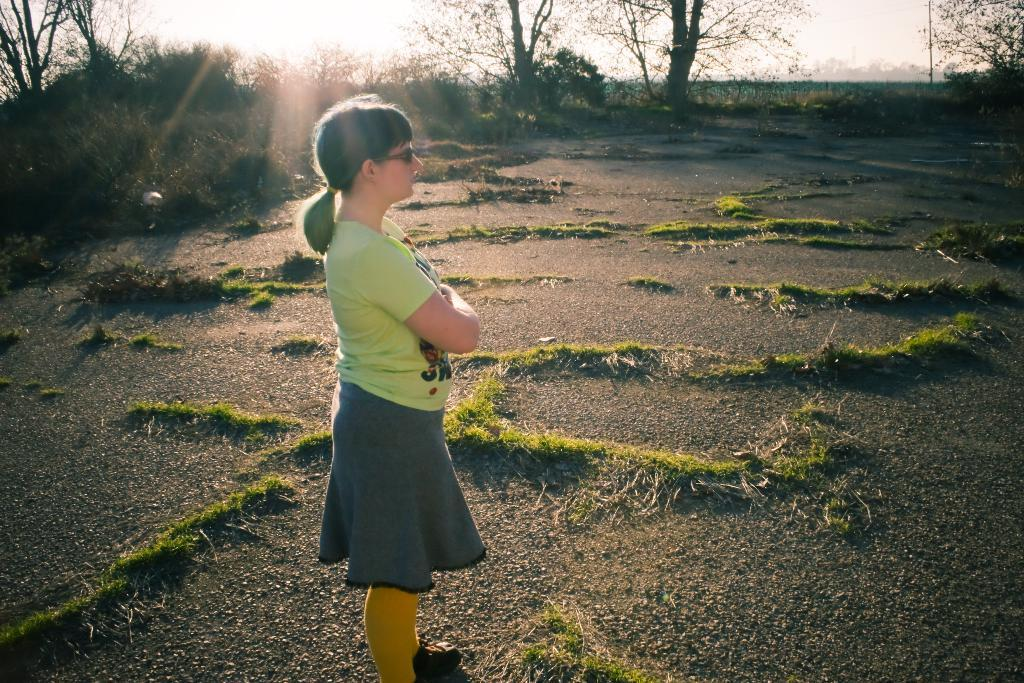Who or what is the main subject in the image? There is a person in the image. What type of surface is the person standing on? The ground is visible in the image. What type of vegetation can be seen in the image? There is grass, plants, and trees in the image. What can be seen in the background of the image? There are objects in the background of the image. What part of the natural environment is visible in the image? The sky is visible in the image. How many units of teeth does the person have in the image? There is no information about the person's teeth in the image, so it cannot be determined. 